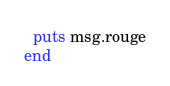Convert code to text. <code><loc_0><loc_0><loc_500><loc_500><_Ruby_>  puts msg.rouge
end
</code> 